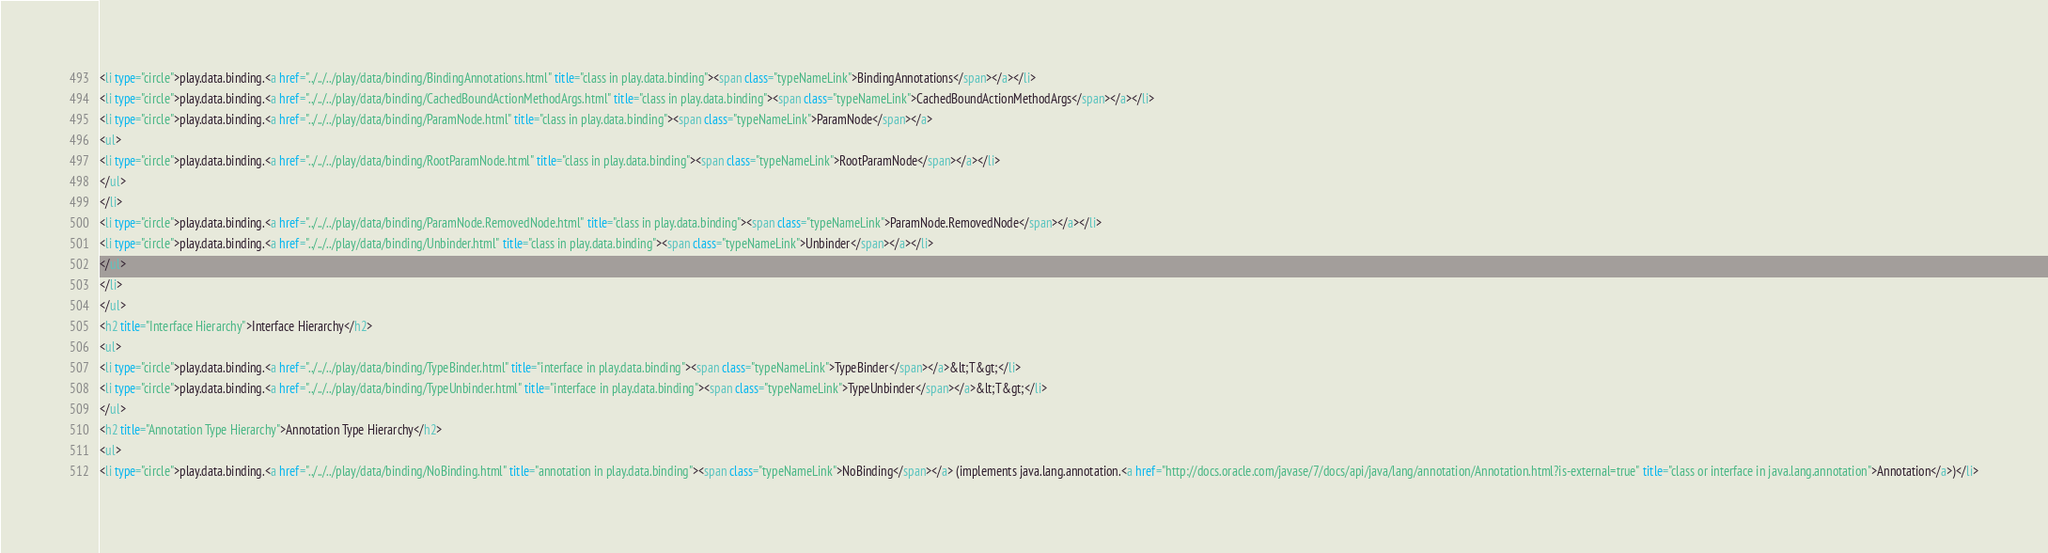<code> <loc_0><loc_0><loc_500><loc_500><_HTML_><li type="circle">play.data.binding.<a href="../../../play/data/binding/BindingAnnotations.html" title="class in play.data.binding"><span class="typeNameLink">BindingAnnotations</span></a></li>
<li type="circle">play.data.binding.<a href="../../../play/data/binding/CachedBoundActionMethodArgs.html" title="class in play.data.binding"><span class="typeNameLink">CachedBoundActionMethodArgs</span></a></li>
<li type="circle">play.data.binding.<a href="../../../play/data/binding/ParamNode.html" title="class in play.data.binding"><span class="typeNameLink">ParamNode</span></a>
<ul>
<li type="circle">play.data.binding.<a href="../../../play/data/binding/RootParamNode.html" title="class in play.data.binding"><span class="typeNameLink">RootParamNode</span></a></li>
</ul>
</li>
<li type="circle">play.data.binding.<a href="../../../play/data/binding/ParamNode.RemovedNode.html" title="class in play.data.binding"><span class="typeNameLink">ParamNode.RemovedNode</span></a></li>
<li type="circle">play.data.binding.<a href="../../../play/data/binding/Unbinder.html" title="class in play.data.binding"><span class="typeNameLink">Unbinder</span></a></li>
</ul>
</li>
</ul>
<h2 title="Interface Hierarchy">Interface Hierarchy</h2>
<ul>
<li type="circle">play.data.binding.<a href="../../../play/data/binding/TypeBinder.html" title="interface in play.data.binding"><span class="typeNameLink">TypeBinder</span></a>&lt;T&gt;</li>
<li type="circle">play.data.binding.<a href="../../../play/data/binding/TypeUnbinder.html" title="interface in play.data.binding"><span class="typeNameLink">TypeUnbinder</span></a>&lt;T&gt;</li>
</ul>
<h2 title="Annotation Type Hierarchy">Annotation Type Hierarchy</h2>
<ul>
<li type="circle">play.data.binding.<a href="../../../play/data/binding/NoBinding.html" title="annotation in play.data.binding"><span class="typeNameLink">NoBinding</span></a> (implements java.lang.annotation.<a href="http://docs.oracle.com/javase/7/docs/api/java/lang/annotation/Annotation.html?is-external=true" title="class or interface in java.lang.annotation">Annotation</a>)</li></code> 